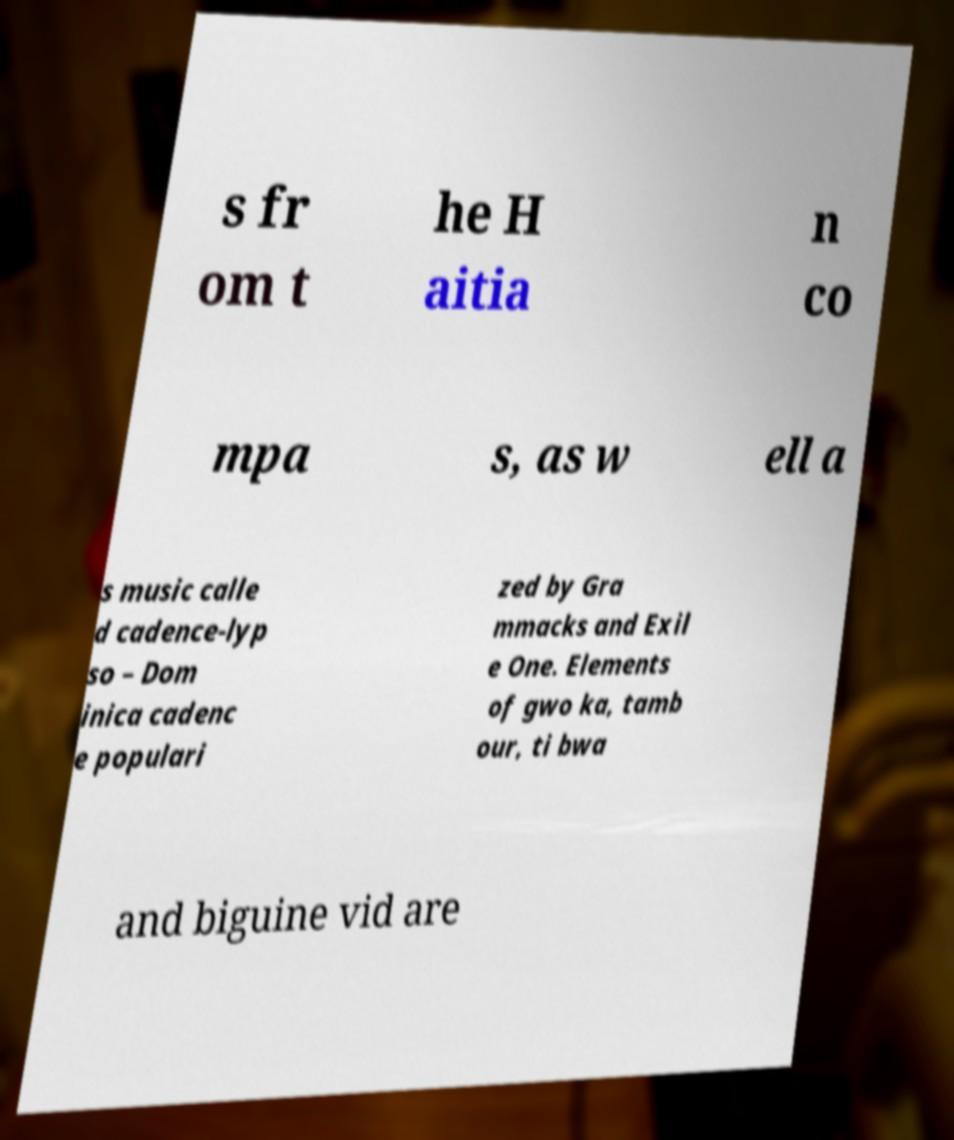Could you extract and type out the text from this image? s fr om t he H aitia n co mpa s, as w ell a s music calle d cadence-lyp so – Dom inica cadenc e populari zed by Gra mmacks and Exil e One. Elements of gwo ka, tamb our, ti bwa and biguine vid are 